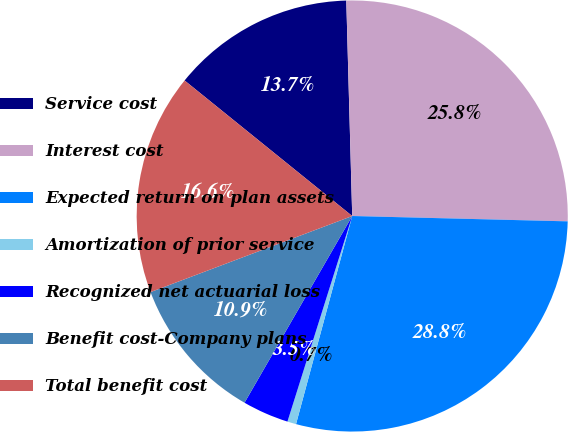Convert chart. <chart><loc_0><loc_0><loc_500><loc_500><pie_chart><fcel>Service cost<fcel>Interest cost<fcel>Expected return on plan assets<fcel>Amortization of prior service<fcel>Recognized net actuarial loss<fcel>Benefit cost-Company plans<fcel>Total benefit cost<nl><fcel>13.74%<fcel>25.83%<fcel>28.8%<fcel>0.66%<fcel>3.47%<fcel>10.93%<fcel>16.56%<nl></chart> 